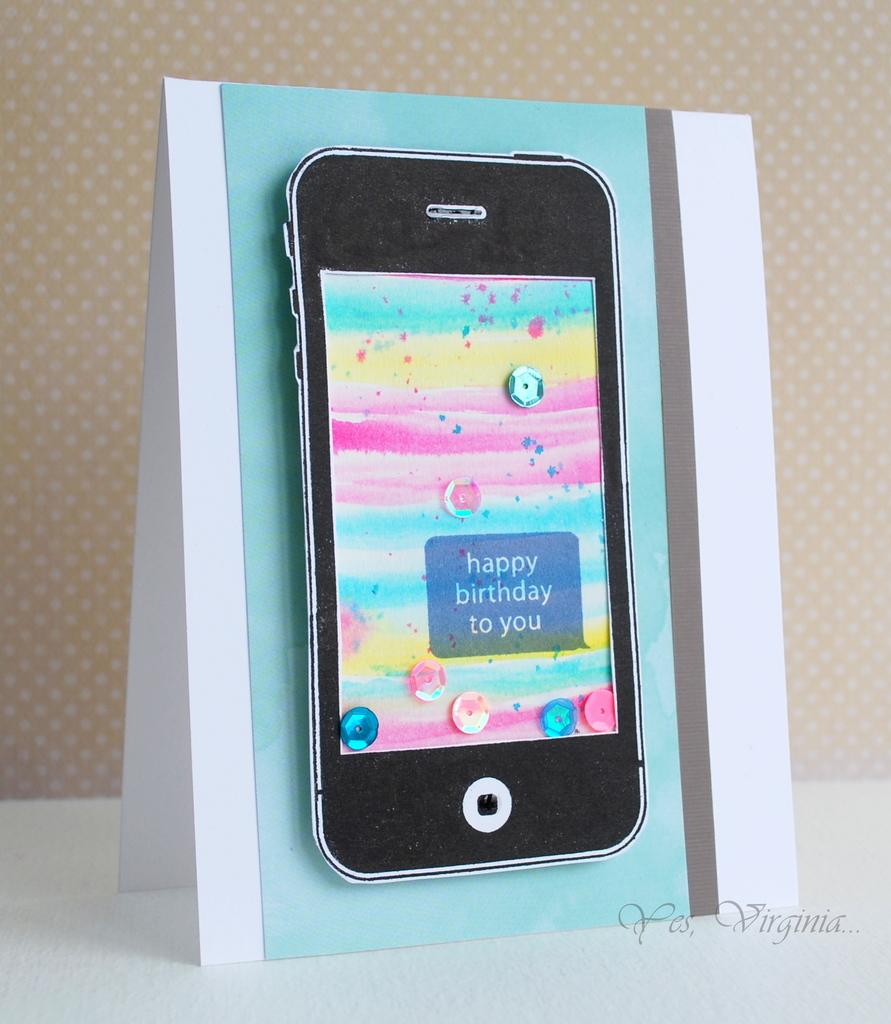Happy birthday to who?
Keep it short and to the point. You. Is this a real phone or just a picture?
Your answer should be very brief. Answering does not require reading text in the image. 